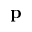Convert formula to latex. <formula><loc_0><loc_0><loc_500><loc_500>p</formula> 